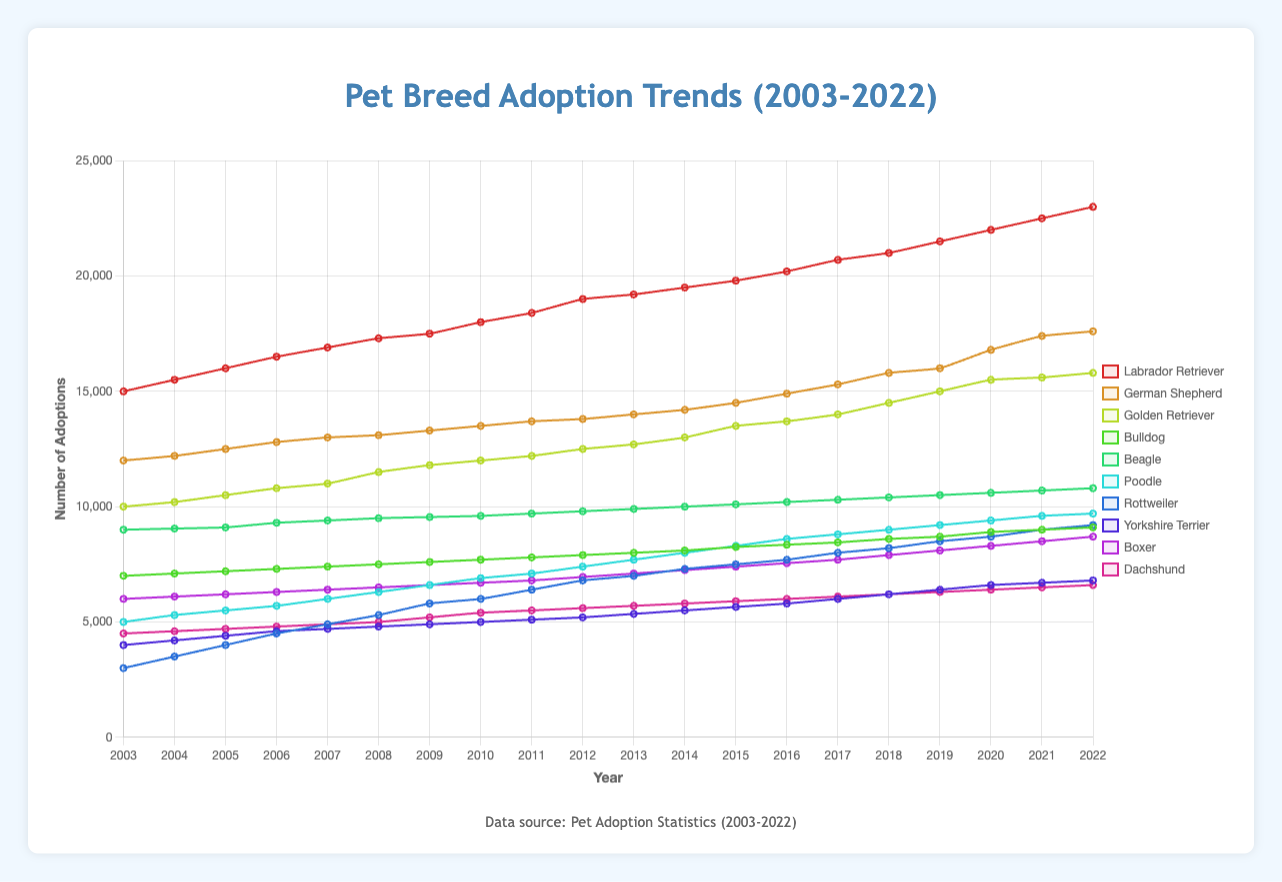What is the breed with the highest number of adoptions in 2022? Check the data points for 2022 for each breed and compare them. The Labrador Retriever has the highest number of adoptions at 23,000.
Answer: Labrador Retriever How much did the number of Rottweiler adoptions increase from 2003 to 2022? Calculate the difference between the adoption numbers in 2022 and 2003. It increased from 3,000 to 9,200, which is an increase of 6,200.
Answer: 6,200 Which breed had a higher number of adoptions in 2010, Beagle or Boxer? Compare the data points for Beagle and Boxer in 2010. Beagle had 9,600 adoptions and Boxer had 6,700.
Answer: Beagle What is the average number of adoptions for the Poodle from 2003 to 2022? Sum the adoption numbers for the Poodle from 2003 to 2022 and divide by the number of years (20). (5000 + 5300 + 5500 + 5700 + 6000 + 6300 + 6600 + 6900 + 7100 + 7400 + 7700 + 8000 + 8300 + 8600 + 8800 + 9000 + 9200 + 9400 + 9600 + 9700) / 20 = 7,020.
Answer: 7,020 Between 2018 and 2020, which breed showed the most significant increase in adoptions? Calculate the difference between 2020 and 2018 adoption numbers for each breed. The German Shepherd increased by 1,800 (16,000 to 17,800), which is the most significant increase in that period.
Answer: German Shepherd How did the adoption trend of the Golden Retriever change from 2003 to 2022? Observe the trend line for Golden Retriever from 2003 to 2022. The trend shows a continuous increase from 10,000 to 15,800 adoptions.
Answer: Increasing Which breed had the lowest number of adoptions in 2003, and what was the number? Check the data points for 2003 for each breed. The Rottweiler had the lowest number with 3,000 adoptees.
Answer: Rottweiler, 3,000 In which year did the Labrador Retriever first surpass 20,000 adoptions? Look at the data points for the Labrador Retriever and find the year when the number first exceeds 20,000. This happened in 2017 with 20,200 adoptions.
Answer: 2017 Comparing 2015 and 2020, how many more adoptions were there for the Boxer breed in 2020? Calculate the difference in the adoption numbers for Boxer between these years. The number increased from 7,400 in 2015 to 8,300 in 2020, which is an increase of 900.
Answer: 900 Which breed had the smallest increase in adoptions over the 20 years? Calculate the difference in adoption numbers from 2003 to 2022 for each breed and compare. The Beagle had the smallest increase from 9,000 to 10,800, which is an increase of 1,800.
Answer: Beagle 